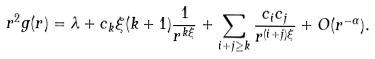Convert formula to latex. <formula><loc_0><loc_0><loc_500><loc_500>r ^ { 2 } g ( r ) = \lambda + c _ { k } \xi ( k + 1 ) \frac { 1 } { r ^ { k \xi } } + \sum _ { i + j \geq k } \frac { c _ { i } c _ { j } } { r ^ { ( i + j ) \xi } } + O ( r ^ { - \alpha } ) .</formula> 